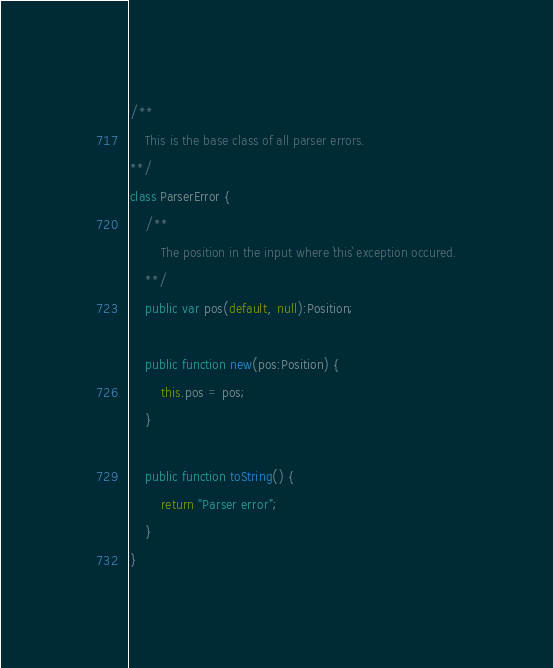Convert code to text. <code><loc_0><loc_0><loc_500><loc_500><_Haxe_>
/**
	This is the base class of all parser errors.
**/
class ParserError {
	/**
		The position in the input where `this` exception occured.
	**/
	public var pos(default, null):Position;

	public function new(pos:Position) {
		this.pos = pos;
	}

	public function toString() {
		return "Parser error";
	}
}</code> 